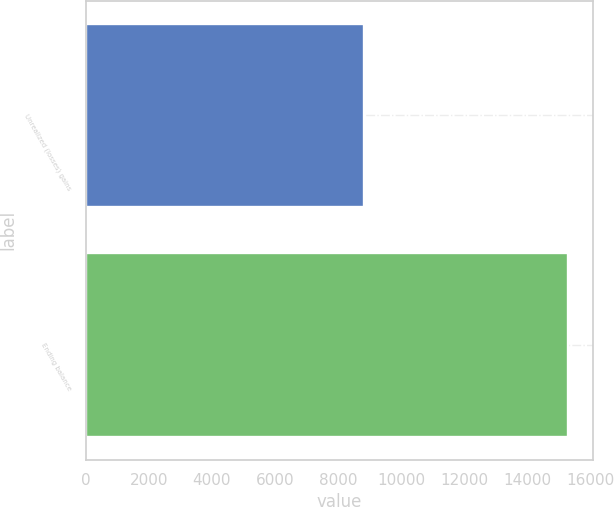Convert chart to OTSL. <chart><loc_0><loc_0><loc_500><loc_500><bar_chart><fcel>Unrealized (losses) gains<fcel>Ending balance<nl><fcel>8835<fcel>15297<nl></chart> 